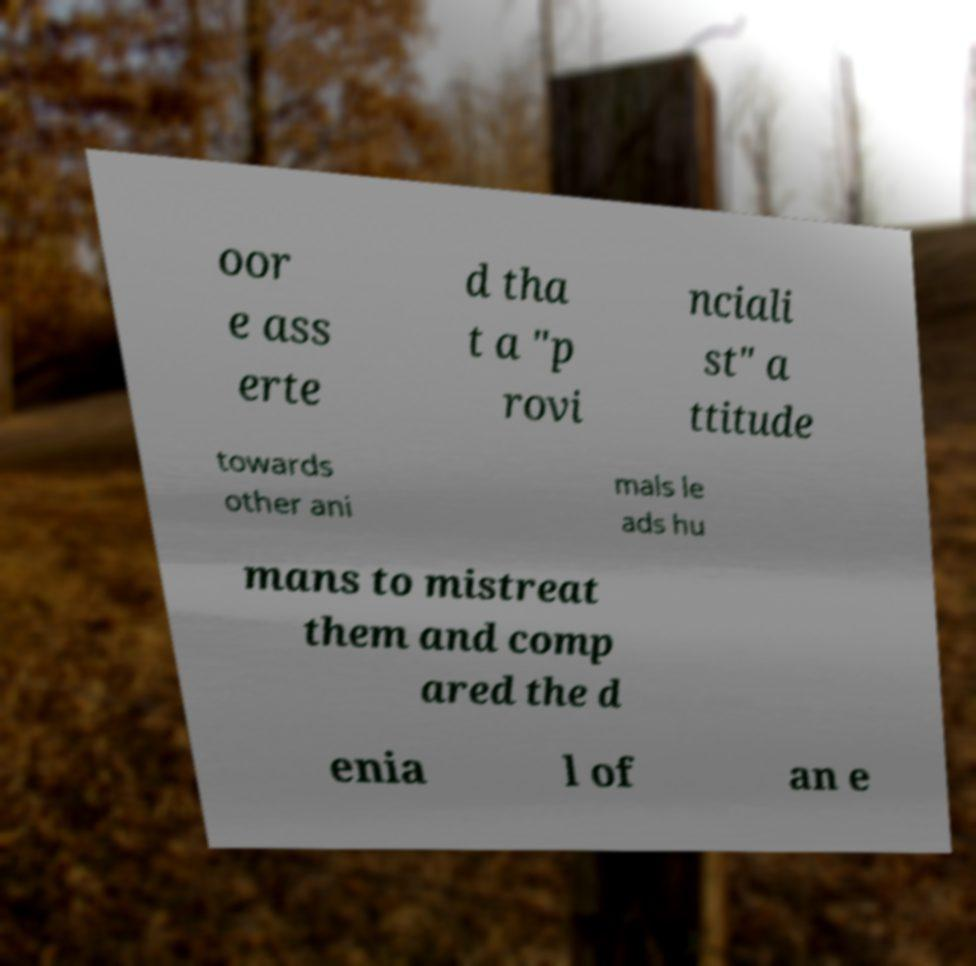Can you accurately transcribe the text from the provided image for me? oor e ass erte d tha t a "p rovi nciali st" a ttitude towards other ani mals le ads hu mans to mistreat them and comp ared the d enia l of an e 